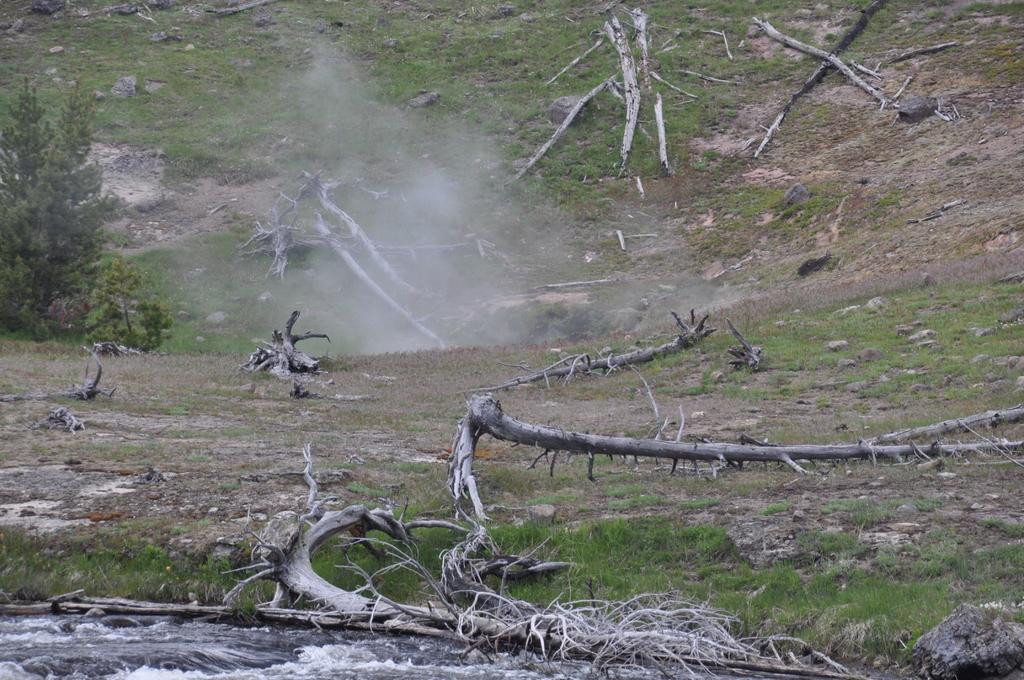In one or two sentences, can you explain what this image depicts? In this image I can see an open grass ground and on it I can see number of tree trunks and branches. On the left side of the image I can see a tree and in the centre of the image I can see the smoke. On the bottom side of the image I can see the water. 